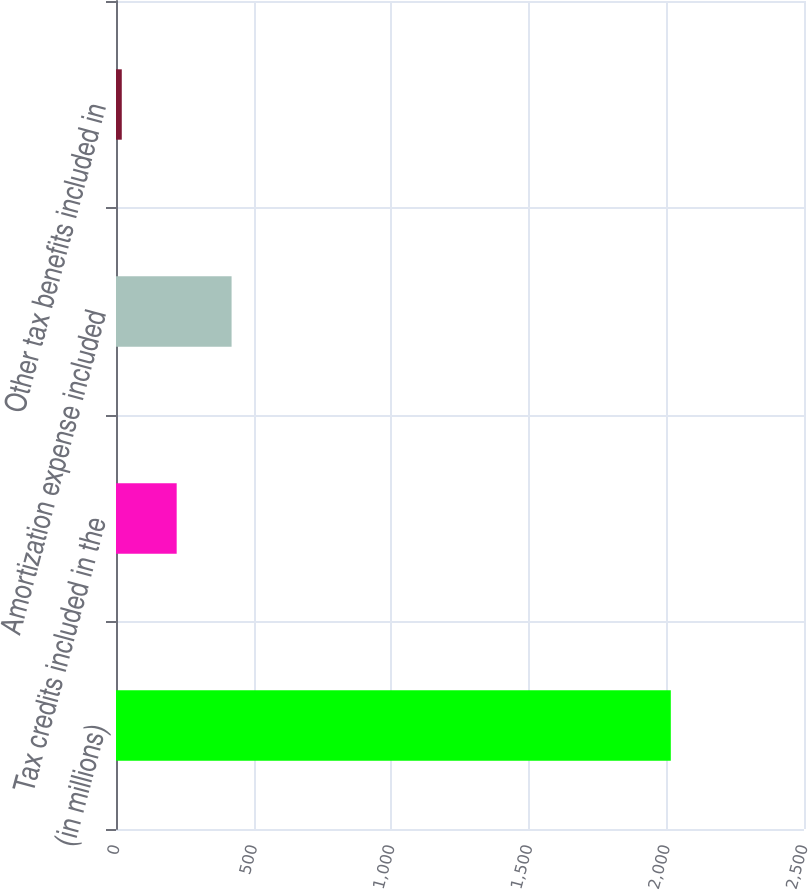Convert chart to OTSL. <chart><loc_0><loc_0><loc_500><loc_500><bar_chart><fcel>(in millions)<fcel>Tax credits included in the<fcel>Amortization expense included<fcel>Other tax benefits included in<nl><fcel>2016<fcel>220.5<fcel>420<fcel>21<nl></chart> 